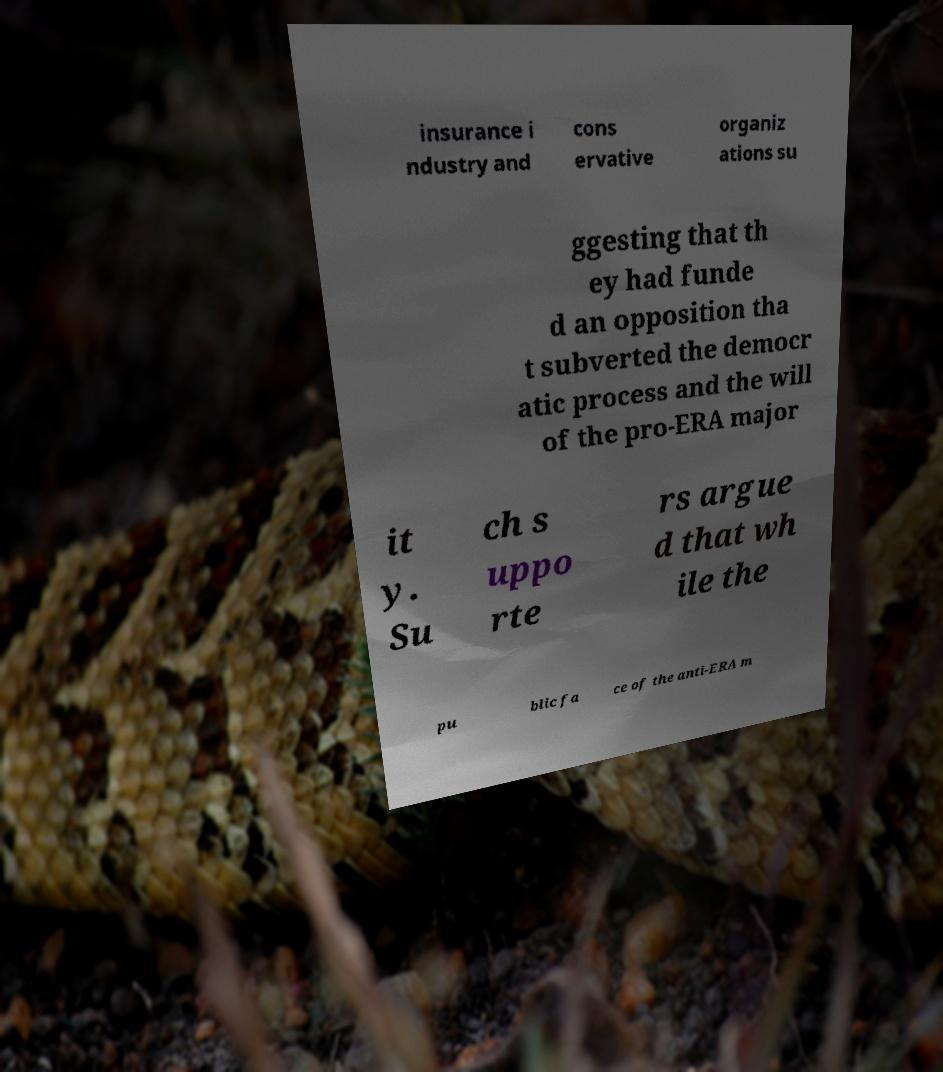There's text embedded in this image that I need extracted. Can you transcribe it verbatim? insurance i ndustry and cons ervative organiz ations su ggesting that th ey had funde d an opposition tha t subverted the democr atic process and the will of the pro-ERA major it y. Su ch s uppo rte rs argue d that wh ile the pu blic fa ce of the anti-ERA m 